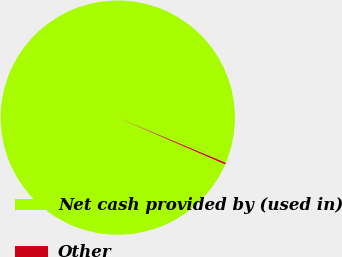Convert chart to OTSL. <chart><loc_0><loc_0><loc_500><loc_500><pie_chart><fcel>Net cash provided by (used in)<fcel>Other<nl><fcel>99.78%<fcel>0.22%<nl></chart> 